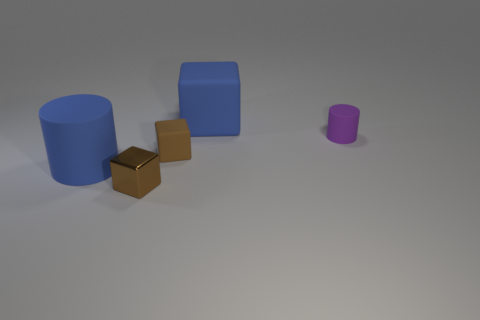What number of large blue rubber objects are the same shape as the purple rubber thing?
Your answer should be very brief. 1. Are there an equal number of tiny purple things to the left of the big blue rubber cylinder and metal cubes?
Offer a very short reply. No. Is there anything else that is the same size as the purple object?
Provide a short and direct response. Yes. What is the shape of the blue rubber thing that is the same size as the blue cylinder?
Your answer should be very brief. Cube. Is there another blue object that has the same shape as the tiny shiny thing?
Offer a terse response. Yes. Is there a small thing that is behind the blue object in front of the blue object that is right of the brown rubber cube?
Offer a terse response. Yes. Is the number of cylinders that are behind the large blue rubber cylinder greater than the number of brown matte things that are behind the large blue block?
Make the answer very short. Yes. What is the material of the blue thing that is the same size as the blue cylinder?
Your answer should be very brief. Rubber. How many large things are shiny objects or cyan metallic balls?
Provide a succinct answer. 0. Is the shape of the brown metal object the same as the tiny brown matte object?
Provide a short and direct response. Yes. 